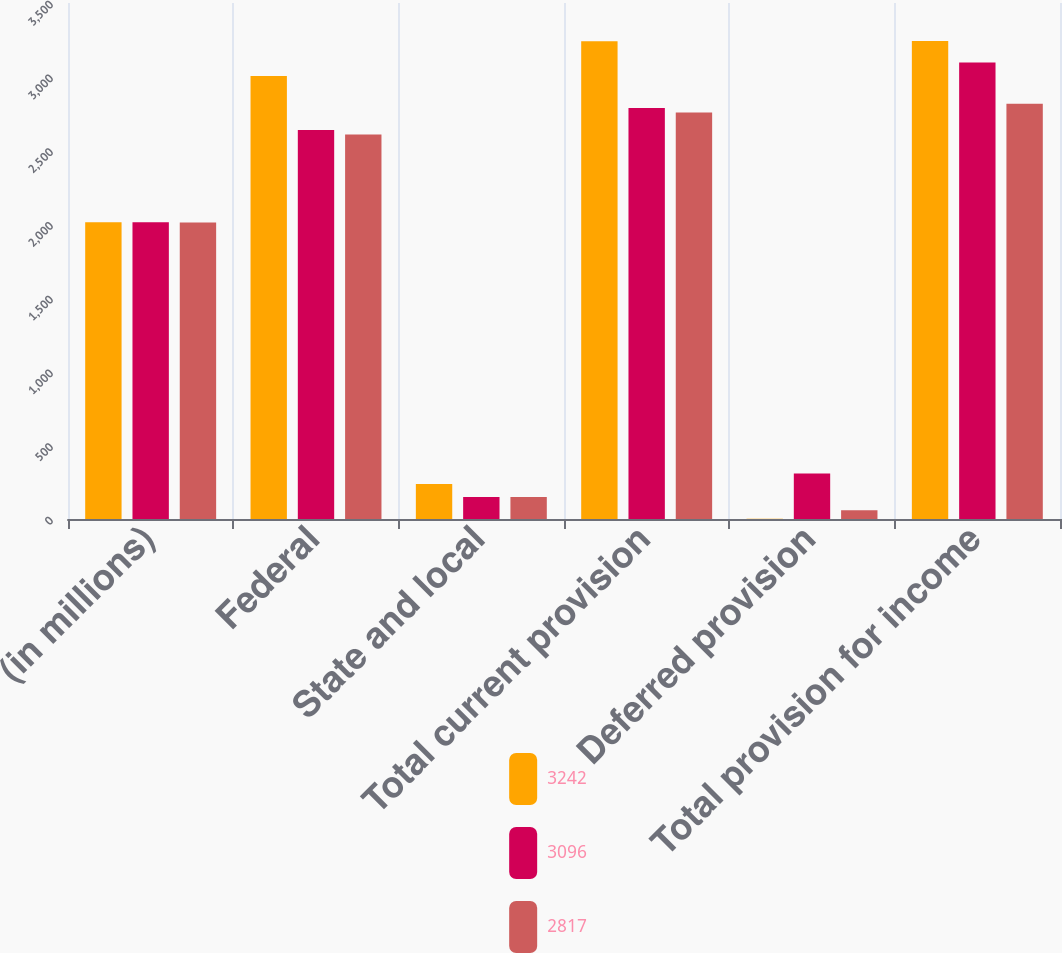<chart> <loc_0><loc_0><loc_500><loc_500><stacked_bar_chart><ecel><fcel>(in millions)<fcel>Federal<fcel>State and local<fcel>Total current provision<fcel>Deferred provision<fcel>Total provision for income<nl><fcel>3242<fcel>2013<fcel>3004<fcel>237<fcel>3241<fcel>1<fcel>3242<nl><fcel>3096<fcel>2012<fcel>2638<fcel>150<fcel>2788<fcel>308<fcel>3096<nl><fcel>2817<fcel>2011<fcel>2608<fcel>150<fcel>2758<fcel>59<fcel>2817<nl></chart> 